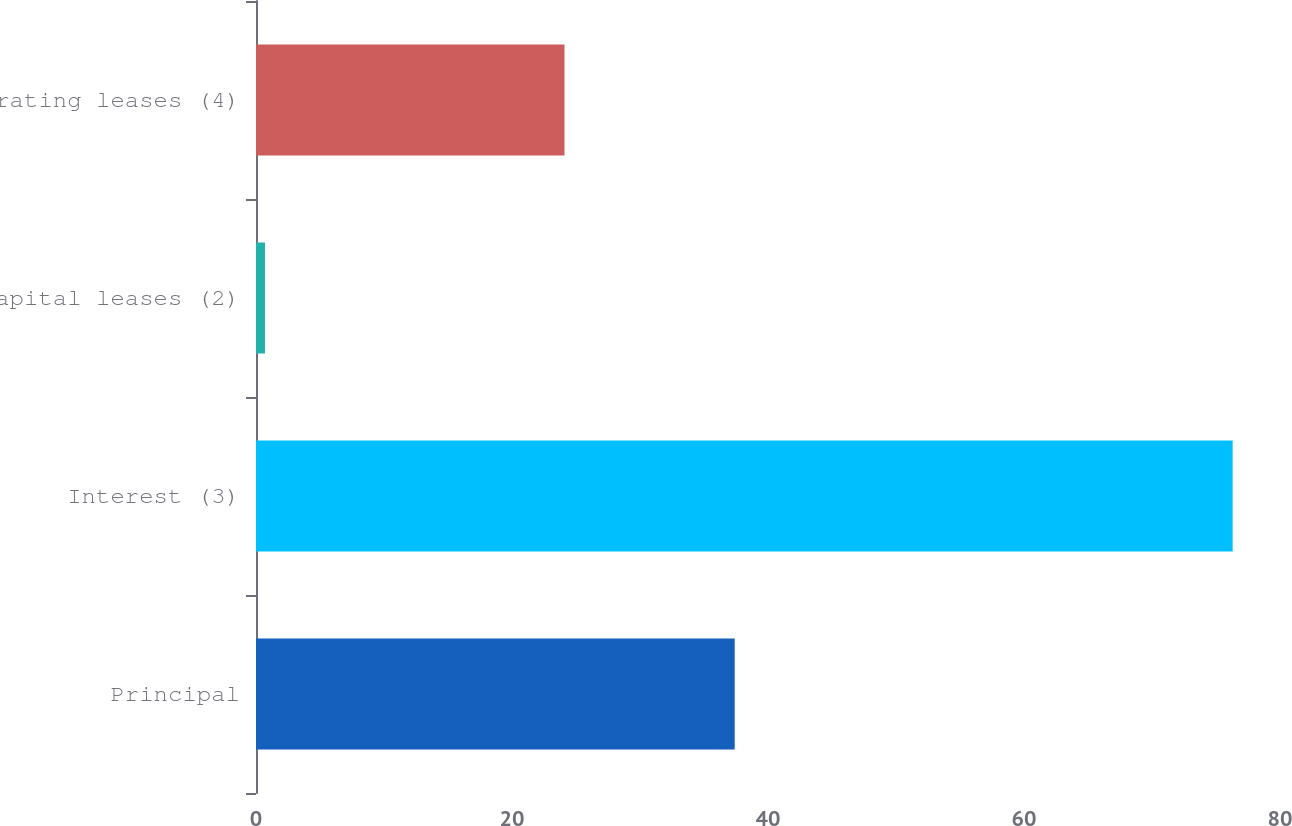Convert chart to OTSL. <chart><loc_0><loc_0><loc_500><loc_500><bar_chart><fcel>Principal<fcel>Interest (3)<fcel>Capital leases (2)<fcel>Operating leases (4)<nl><fcel>37.4<fcel>76.3<fcel>0.7<fcel>24.1<nl></chart> 